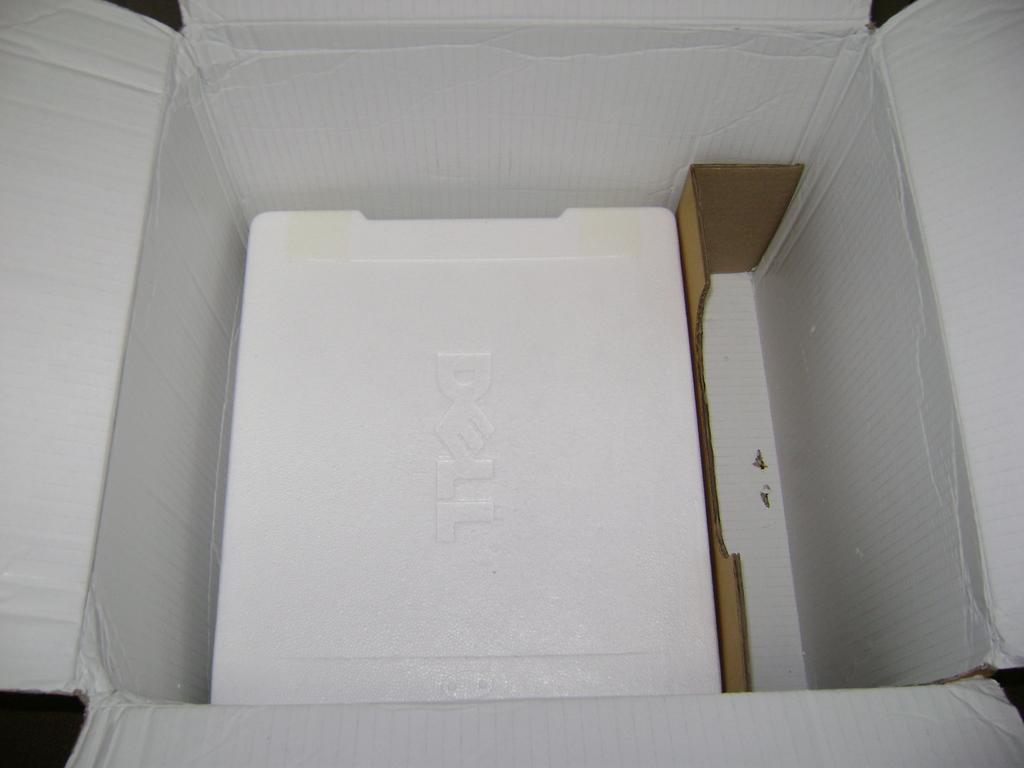<image>
Relay a brief, clear account of the picture shown. An open box with styrofoam covering a Dell compter. 